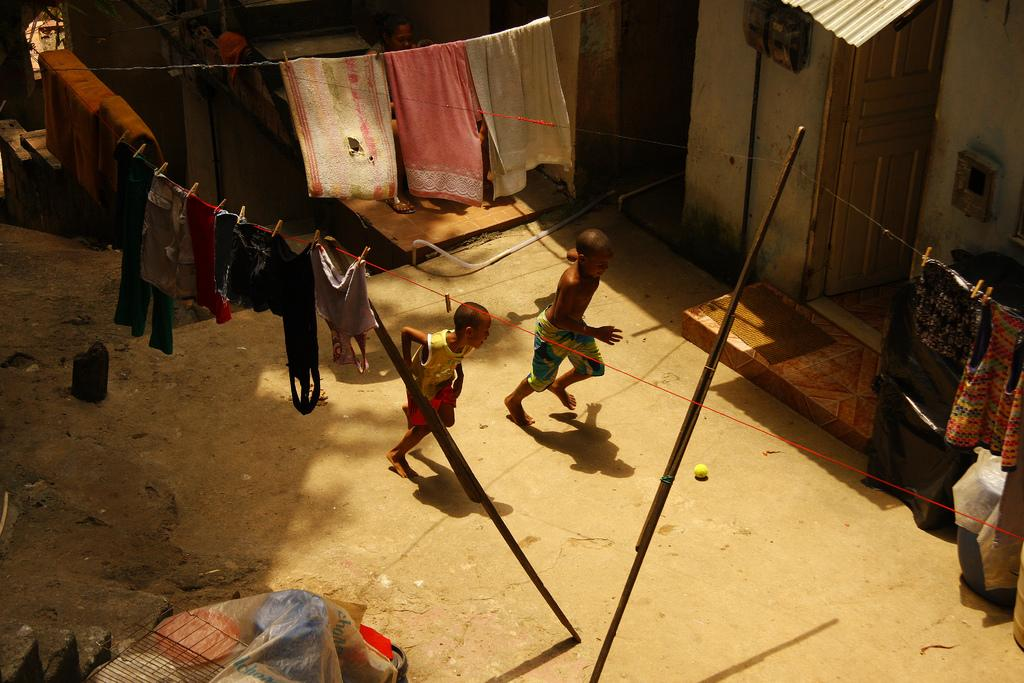How many kids are in the image? There are two kids in the image. What are the kids doing? The kids are running. Why are the kids running? They are running for a ball. What can be seen in the background of the image? There are houses in the background of the image. What is hanging in the top part of the image? Clothes are hanged on a rope in the top part of the image. What type of corn can be seen growing in the image? There is no corn present in the image. What does the hope of the kids look like in the image? The image does not depict the kids' hope or emotions; it only shows their actions. 